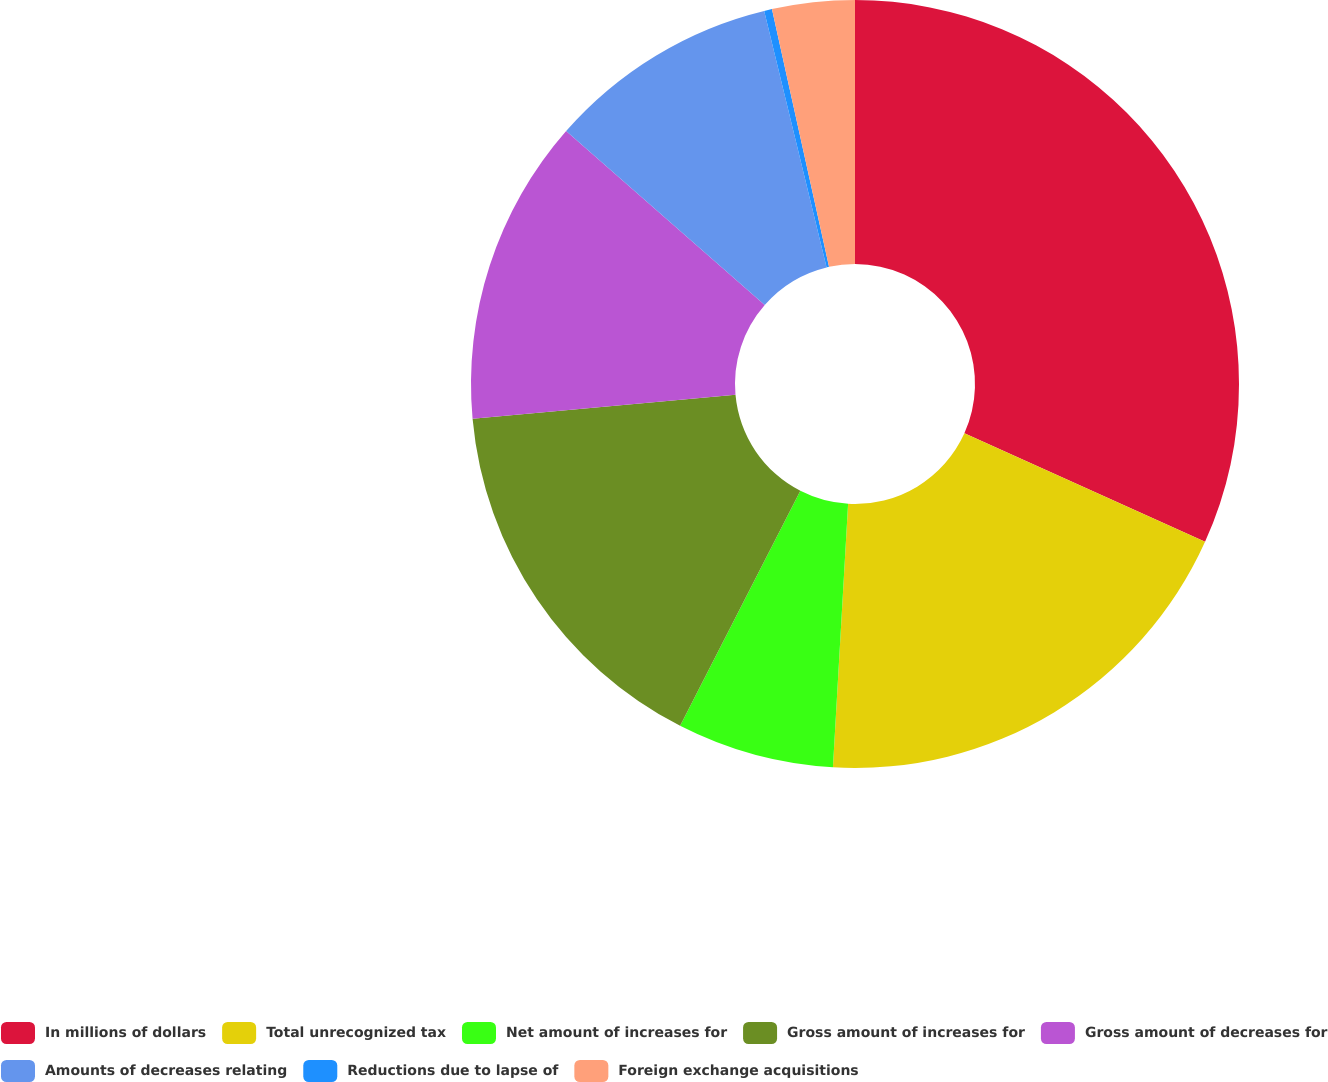<chart> <loc_0><loc_0><loc_500><loc_500><pie_chart><fcel>In millions of dollars<fcel>Total unrecognized tax<fcel>Net amount of increases for<fcel>Gross amount of increases for<fcel>Gross amount of decreases for<fcel>Amounts of decreases relating<fcel>Reductions due to lapse of<fcel>Foreign exchange acquisitions<nl><fcel>31.74%<fcel>19.17%<fcel>6.61%<fcel>16.03%<fcel>12.89%<fcel>9.75%<fcel>0.33%<fcel>3.47%<nl></chart> 